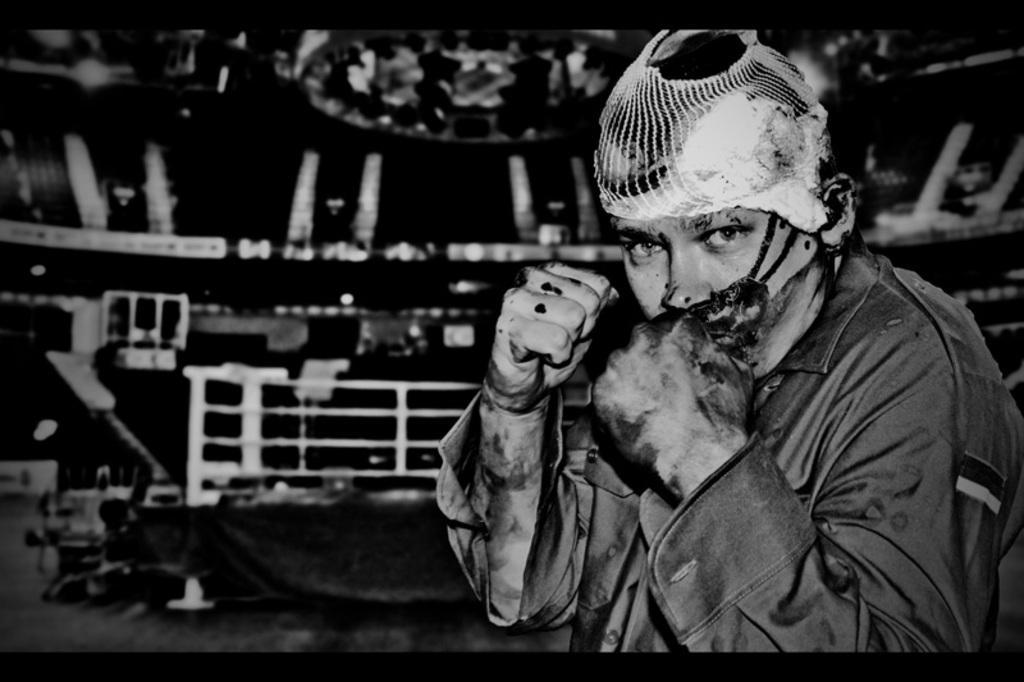Can you describe this image briefly? In this picture we can see a man, and it is black and white photography. 